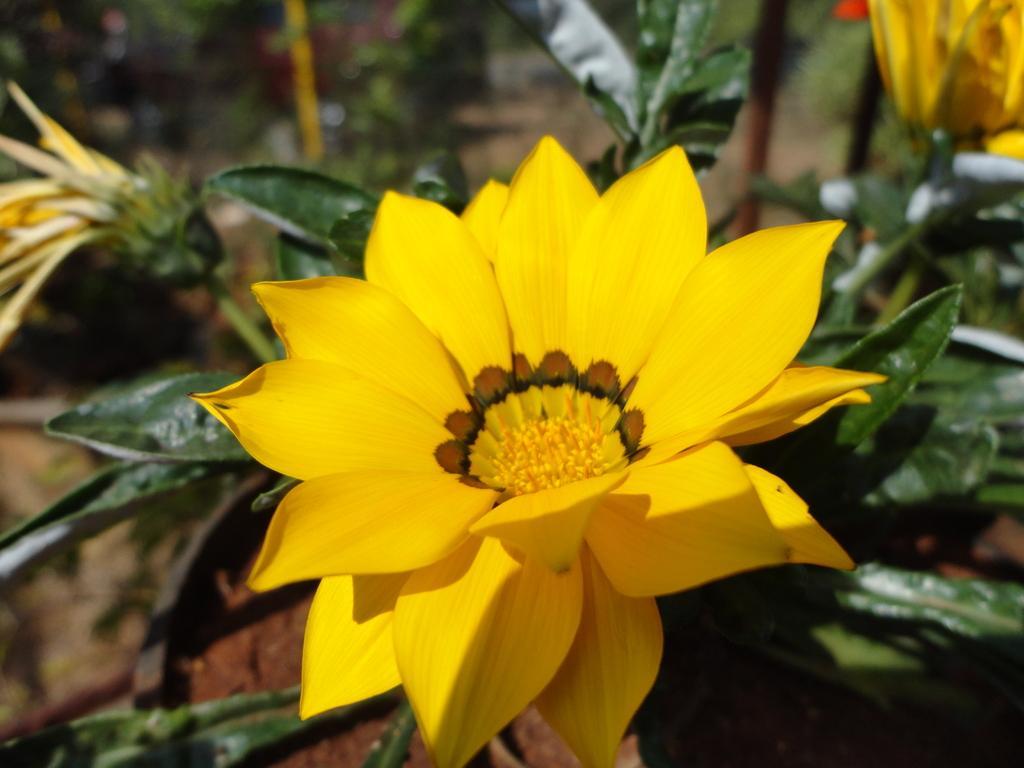Can you describe this image briefly? As we can see in the image there are plants and yellow color flowers. 